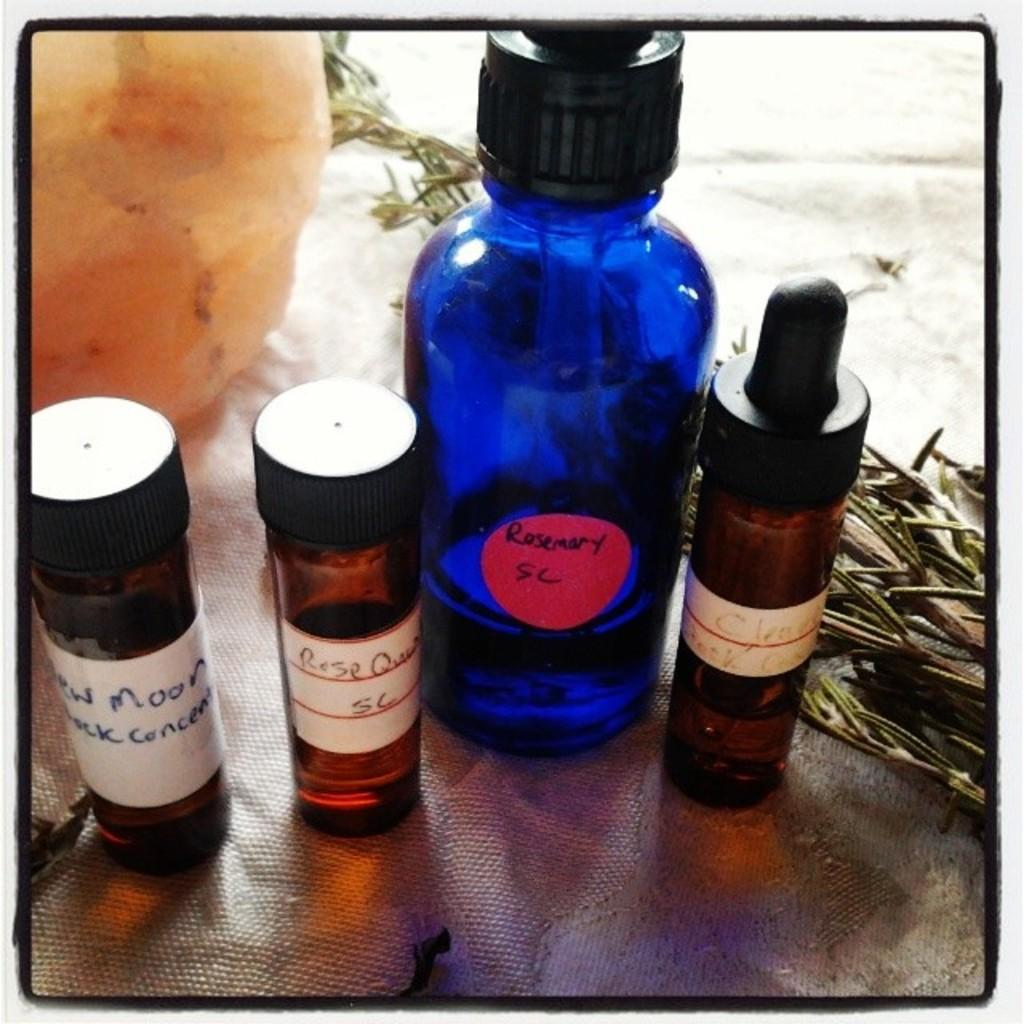How many bottles can be seen in the image? There are four bottles in the image. What is located near the bottles? There are herbs present near the bottles. What type of cart is used to transport the bottles and herbs in the image? There is no cart present in the image; it only shows four bottles and herbs. 